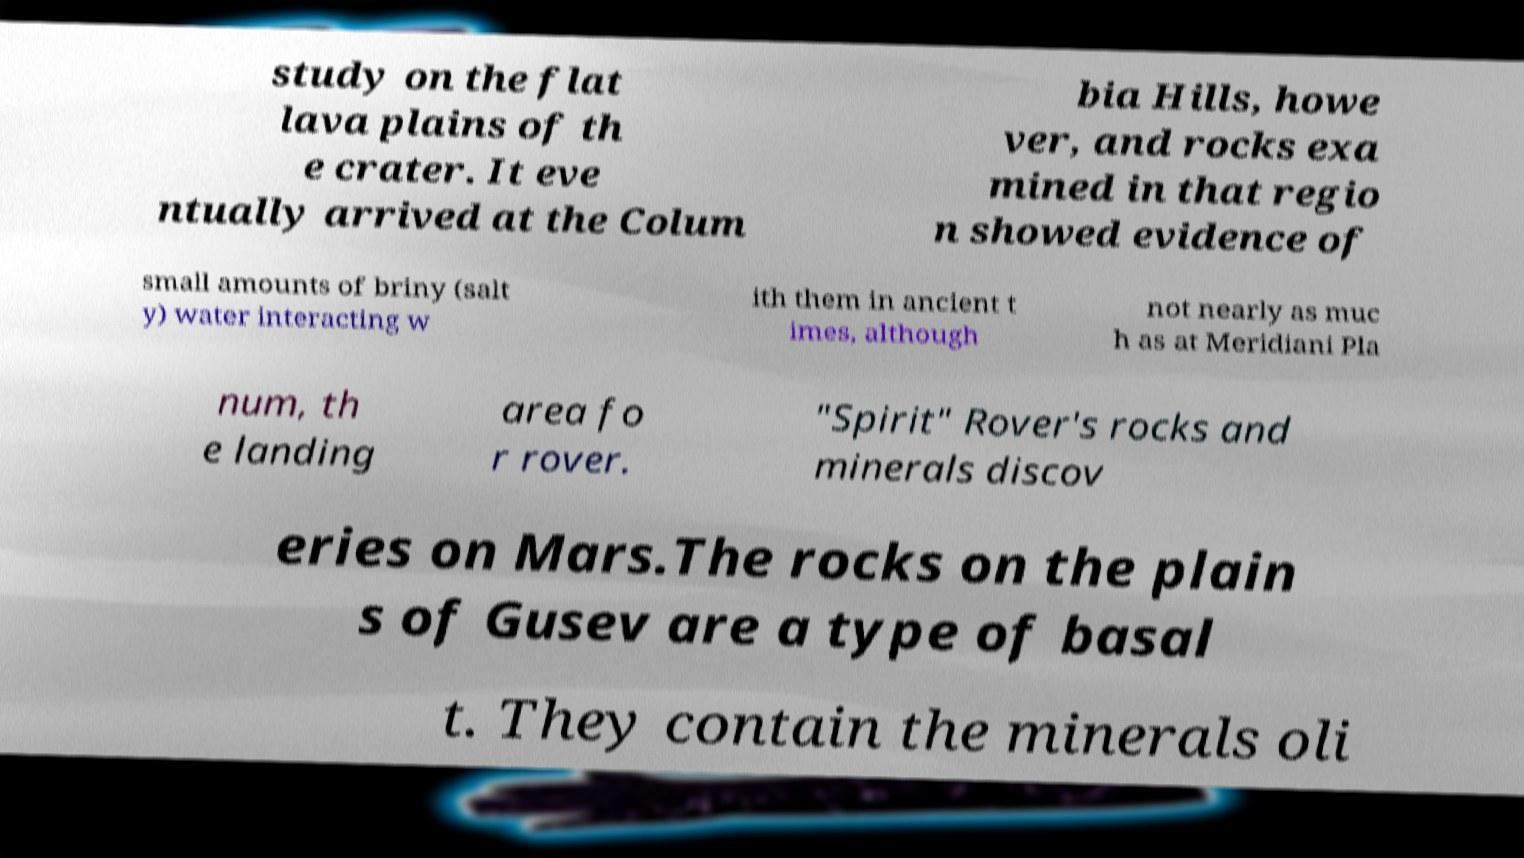Could you extract and type out the text from this image? study on the flat lava plains of th e crater. It eve ntually arrived at the Colum bia Hills, howe ver, and rocks exa mined in that regio n showed evidence of small amounts of briny (salt y) water interacting w ith them in ancient t imes, although not nearly as muc h as at Meridiani Pla num, th e landing area fo r rover. "Spirit" Rover's rocks and minerals discov eries on Mars.The rocks on the plain s of Gusev are a type of basal t. They contain the minerals oli 